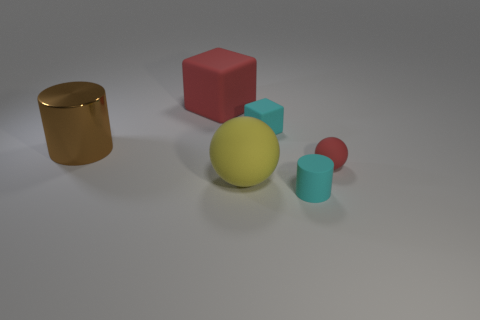Is the small matte cube the same color as the rubber cylinder?
Offer a very short reply. Yes. Is there anything else that has the same material as the large brown thing?
Offer a very short reply. No. What material is the object that is the same color as the tiny matte cube?
Provide a short and direct response. Rubber. What number of cubes are in front of the big yellow sphere?
Offer a terse response. 0. How many yellow shiny balls are there?
Your response must be concise. 0. Does the red matte block have the same size as the brown metal thing?
Give a very brief answer. Yes. Are there any matte cylinders that are behind the cyan rubber thing in front of the red object that is right of the tiny cube?
Your answer should be compact. No. What is the color of the matte ball in front of the tiny sphere?
Make the answer very short. Yellow. The yellow ball is what size?
Your answer should be very brief. Large. Does the brown metallic thing have the same size as the red matte ball in front of the large red matte object?
Ensure brevity in your answer.  No. 